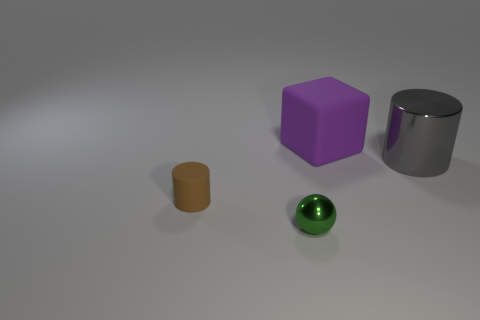How big is the shiny thing behind the small brown rubber object?
Your response must be concise. Large. Is there a small cylinder that has the same color as the tiny matte thing?
Keep it short and to the point. No. Does the brown cylinder have the same material as the small object that is in front of the tiny brown object?
Provide a short and direct response. No. How many large objects are brown matte cubes or metal balls?
Keep it short and to the point. 0. Is the number of small green things less than the number of yellow metallic balls?
Give a very brief answer. No. There is a matte object to the left of the big purple cube; is it the same size as the object to the right of the purple cube?
Offer a very short reply. No. How many green objects are tiny rubber objects or tiny metallic spheres?
Your answer should be compact. 1. Are there more big yellow rubber cubes than large objects?
Provide a short and direct response. No. How many things are either small green metal things or cylinders that are on the left side of the large matte thing?
Keep it short and to the point. 2. How many other things are the same shape as the green metallic object?
Your answer should be compact. 0. 